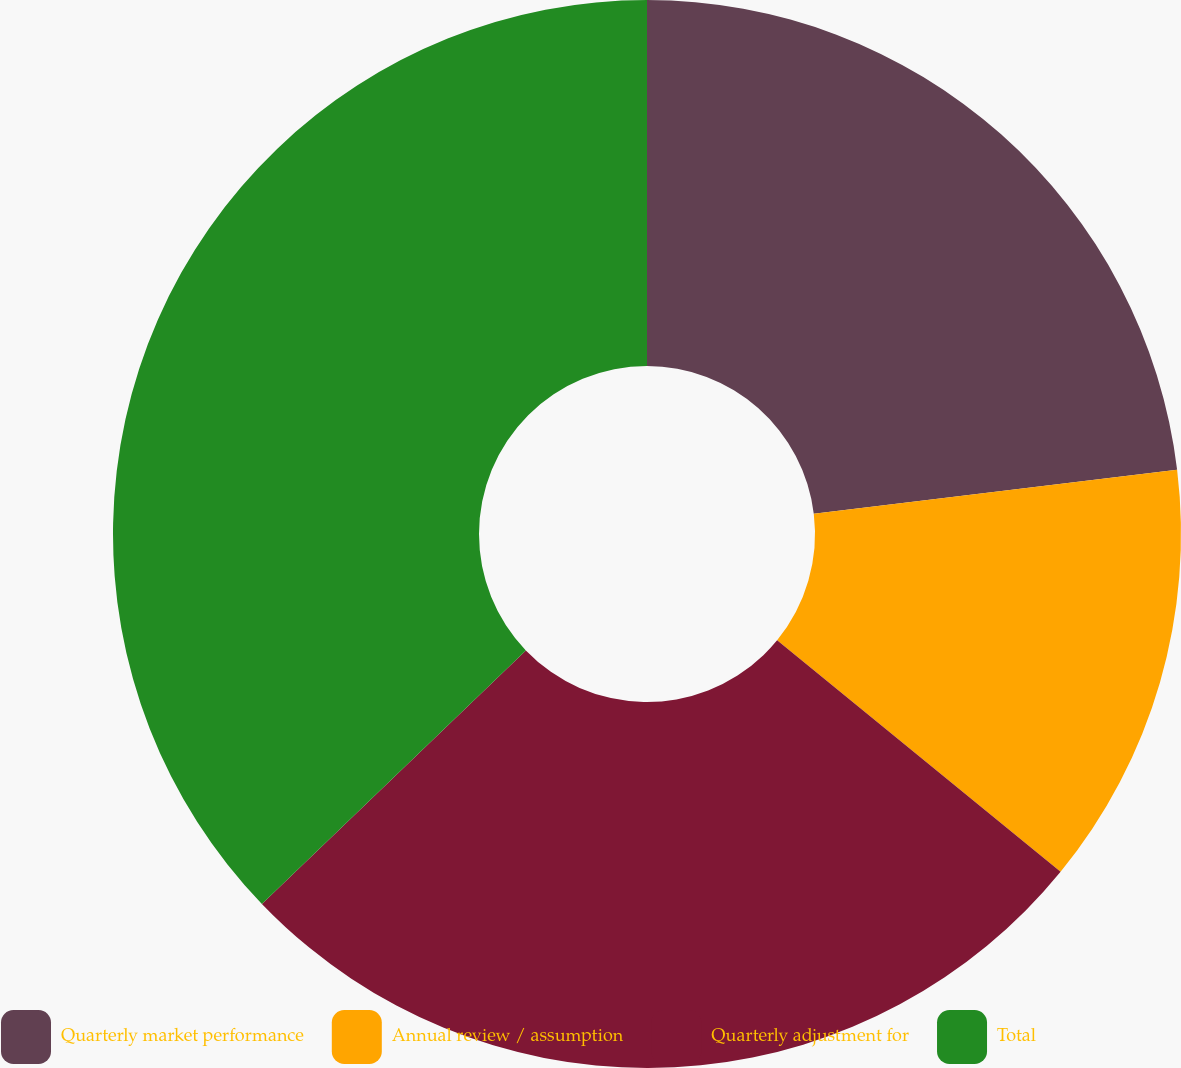Convert chart. <chart><loc_0><loc_0><loc_500><loc_500><pie_chart><fcel>Quarterly market performance<fcel>Annual review / assumption<fcel>Quarterly adjustment for<fcel>Total<nl><fcel>23.08%<fcel>12.82%<fcel>26.92%<fcel>37.18%<nl></chart> 